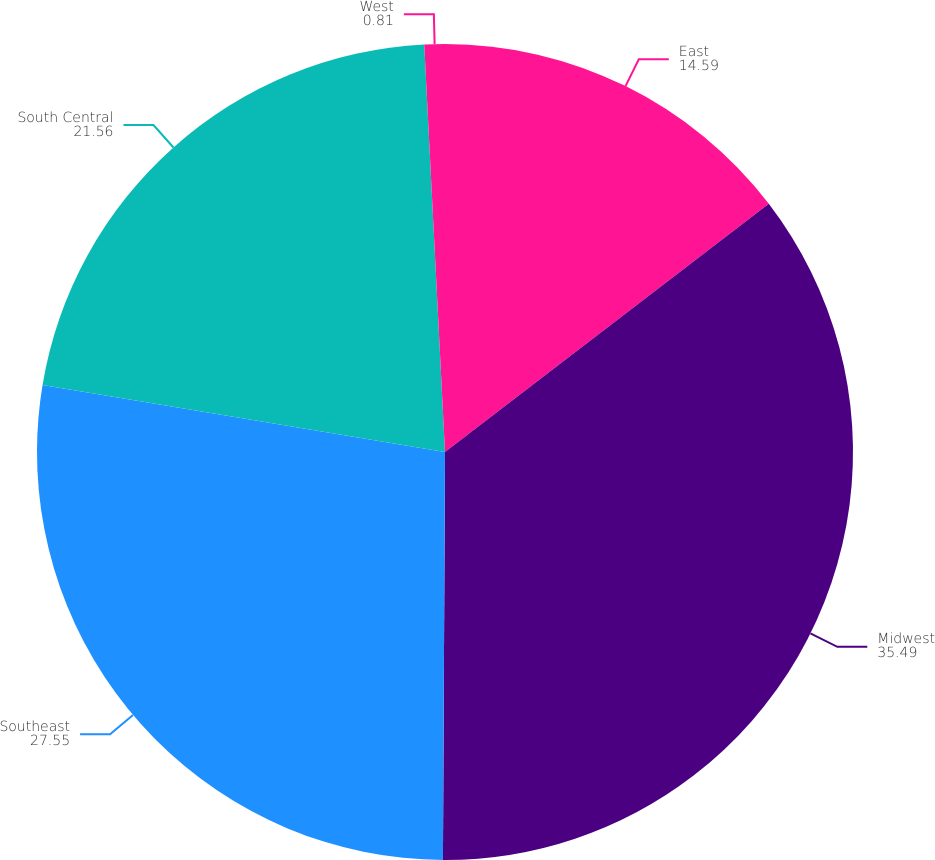Convert chart. <chart><loc_0><loc_0><loc_500><loc_500><pie_chart><fcel>East<fcel>Midwest<fcel>Southeast<fcel>South Central<fcel>West<nl><fcel>14.59%<fcel>35.49%<fcel>27.55%<fcel>21.56%<fcel>0.81%<nl></chart> 